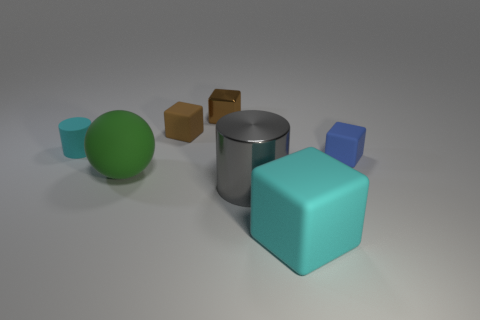Subtract all blue blocks. How many blocks are left? 3 Add 2 tiny blue metal cubes. How many objects exist? 9 Subtract all blue cubes. How many cubes are left? 3 Subtract all yellow cylinders. How many brown blocks are left? 2 Subtract all cylinders. How many objects are left? 5 Subtract all small gray blocks. Subtract all small brown shiny objects. How many objects are left? 6 Add 2 cyan objects. How many cyan objects are left? 4 Add 2 large green rubber cylinders. How many large green rubber cylinders exist? 2 Subtract 0 purple blocks. How many objects are left? 7 Subtract 1 balls. How many balls are left? 0 